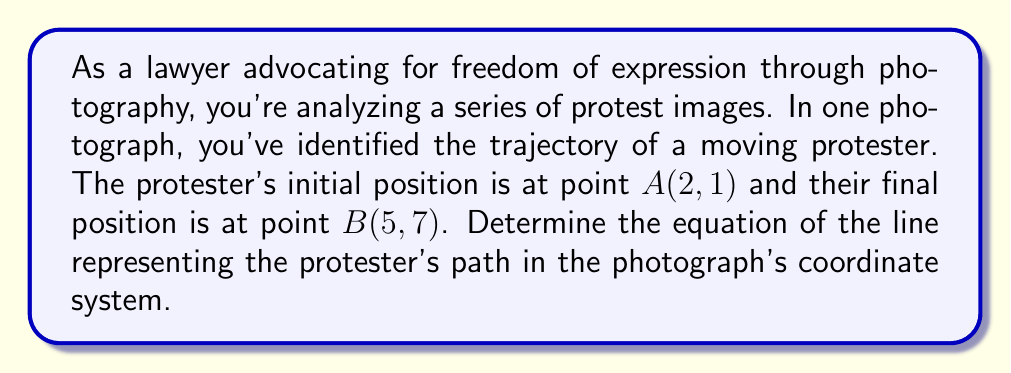Show me your answer to this math problem. To find the equation of a line passing through two points, we'll use the point-slope form of a line equation. Let's approach this step-by-step:

1) The point-slope form of a line is:
   $y - y_1 = m(x - x_1)$

   Where $(x_1, y_1)$ is a point on the line and $m$ is the slope.

2) We need to calculate the slope $m$ first. The slope formula is:
   $m = \frac{y_2 - y_1}{x_2 - x_1}$

3) Using the given points $A(2, 1)$ and $B(5, 7)$:
   $m = \frac{7 - 1}{5 - 2} = \frac{6}{3} = 2$

4) Now we can use either point and the slope in the point-slope form. Let's use $A(2, 1)$:
   $y - 1 = 2(x - 2)$

5) To get the slope-intercept form $(y = mx + b)$, we expand the right side:
   $y - 1 = 2x - 4$

6) Add 1 to both sides:
   $y = 2x - 4 + 1$
   $y = 2x - 3$

This equation represents the line passing through the two points, depicting the protester's trajectory in the photograph's coordinate system.
Answer: $y = 2x - 3$ 